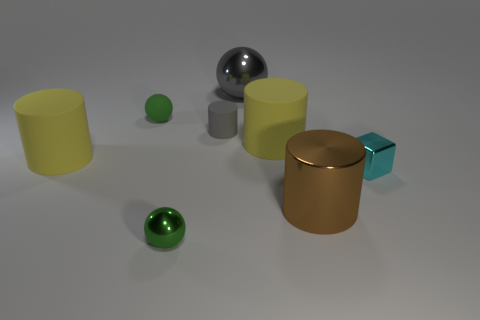What materials are the objects in this image likely made of? The objects in the image appear to be made of different materials. The balls and cylindrical objects exhibit surface properties suggestive of metals and possibly plastics. For example, the large brown cylinder and the silver ball have reflective surfaces indicative of metal, whereas the green balls could be made of a translucent material like glass or polished stone. 